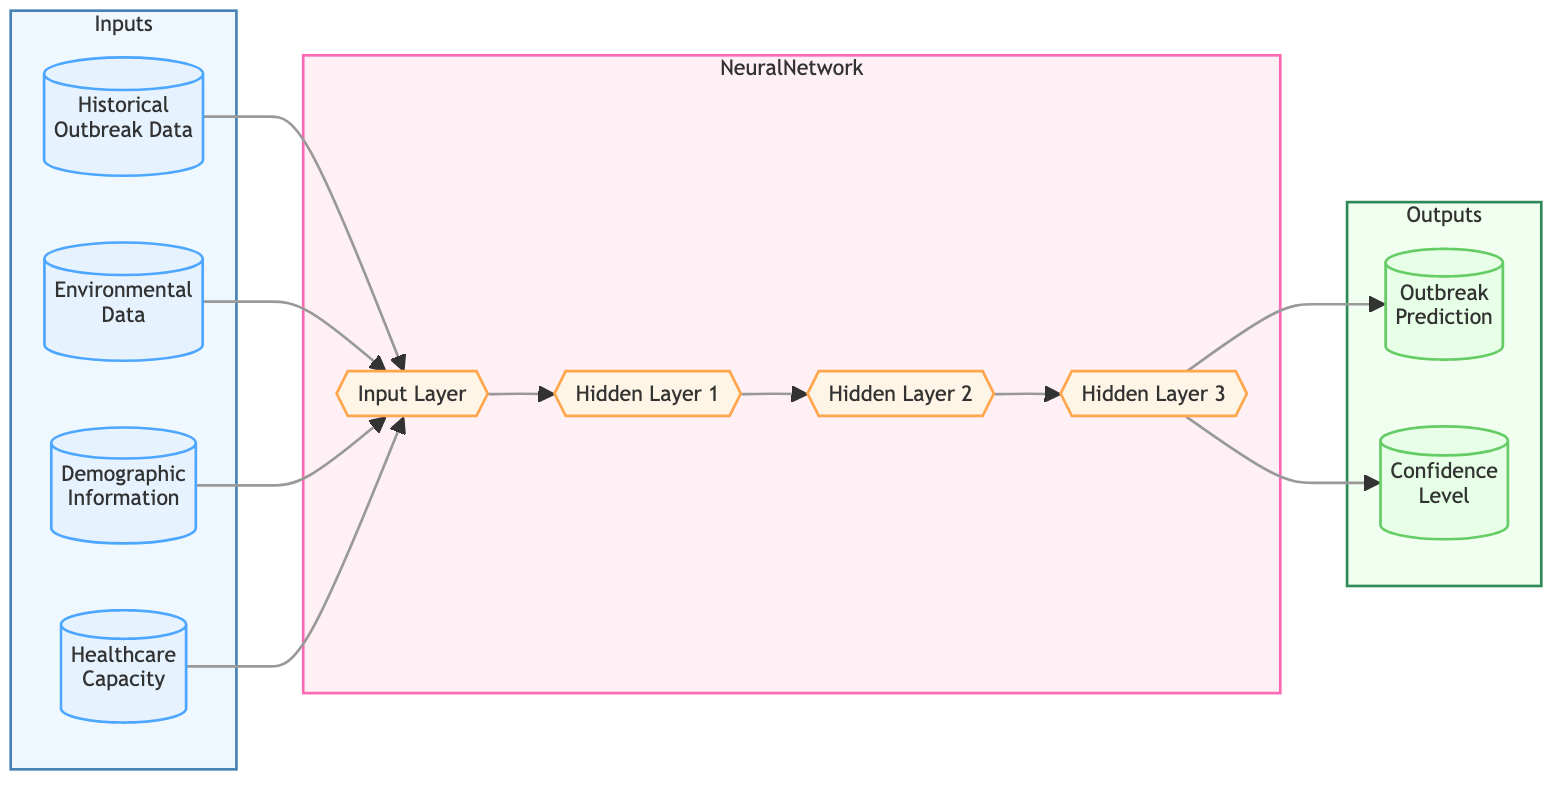What are the types of input data used in this neural network? The diagram indicates four types of input data: Historical Outbreak Data, Environmental Data, Demographic Information, and Healthcare Capacity. Each input node is clearly labeled in the diagram.
Answer: Historical Outbreak Data, Environmental Data, Demographic Information, Healthcare Capacity How many hidden layers are there in the neural network? The diagram shows three distinct hidden layers, labeled as Hidden Layer 1, Hidden Layer 2, and Hidden Layer 3, indicating there are three hidden layers in total.
Answer: 3 What is the final output of the neural network? The diagram identifies two outputs, namely Outbreak Prediction and Confidence Level. They are the final points emerging from the last layer of the neural network.
Answer: Outbreak Prediction, Confidence Level Which input data feeds into the input layer? All four input data types from the Inputs subgraph feed into the Input Layer. Each arrow from an input node points directly to the Input Layer in the diagram.
Answer: Historical Outbreak Data, Environmental Data, Demographic Information, Healthcare Capacity What is the relationship between the last hidden layer and the outputs? The last hidden layer directly connects to both output nodes, indicating that the computations from Hidden Layer 3 flow into the generation of both Outbreak Prediction and Confidence Level outputs. This means both outputs rely on the results of the last hidden layer.
Answer: Direct connection to both outputs 